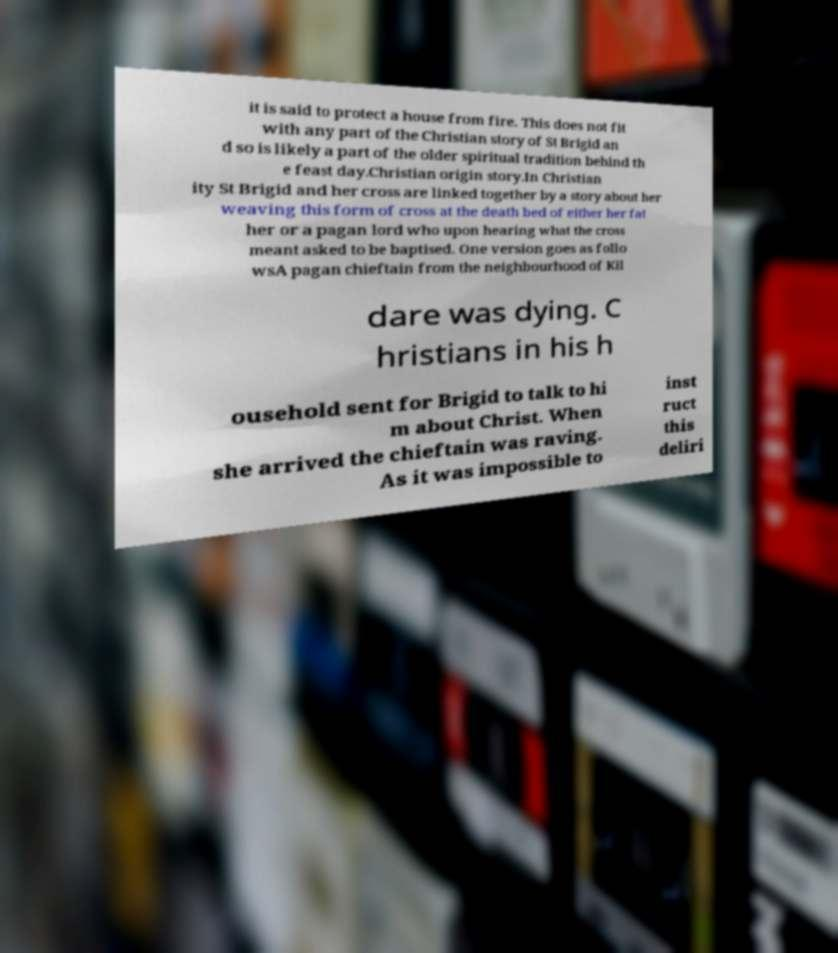Could you extract and type out the text from this image? it is said to protect a house from fire. This does not fit with any part of the Christian story of St Brigid an d so is likely a part of the older spiritual tradition behind th e feast day.Christian origin story.In Christian ity St Brigid and her cross are linked together by a story about her weaving this form of cross at the death bed of either her fat her or a pagan lord who upon hearing what the cross meant asked to be baptised. One version goes as follo wsA pagan chieftain from the neighbourhood of Kil dare was dying. C hristians in his h ousehold sent for Brigid to talk to hi m about Christ. When she arrived the chieftain was raving. As it was impossible to inst ruct this deliri 